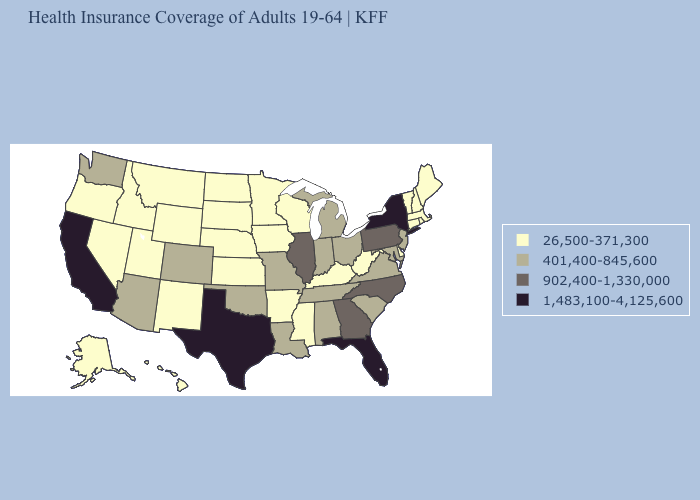What is the highest value in the USA?
Write a very short answer. 1,483,100-4,125,600. Among the states that border New York , does Pennsylvania have the highest value?
Give a very brief answer. Yes. Name the states that have a value in the range 1,483,100-4,125,600?
Write a very short answer. California, Florida, New York, Texas. Does the first symbol in the legend represent the smallest category?
Quick response, please. Yes. What is the lowest value in the USA?
Write a very short answer. 26,500-371,300. Does Illinois have the highest value in the MidWest?
Be succinct. Yes. Does New Mexico have the highest value in the West?
Concise answer only. No. Among the states that border West Virginia , does Kentucky have the lowest value?
Quick response, please. Yes. Does Alabama have the same value as Michigan?
Give a very brief answer. Yes. Does Utah have the lowest value in the West?
Give a very brief answer. Yes. Which states have the lowest value in the West?
Give a very brief answer. Alaska, Hawaii, Idaho, Montana, Nevada, New Mexico, Oregon, Utah, Wyoming. Among the states that border Maryland , which have the highest value?
Give a very brief answer. Pennsylvania. Does Wyoming have the same value as Kentucky?
Write a very short answer. Yes. What is the value of Oklahoma?
Keep it brief. 401,400-845,600. What is the value of Tennessee?
Be succinct. 401,400-845,600. 